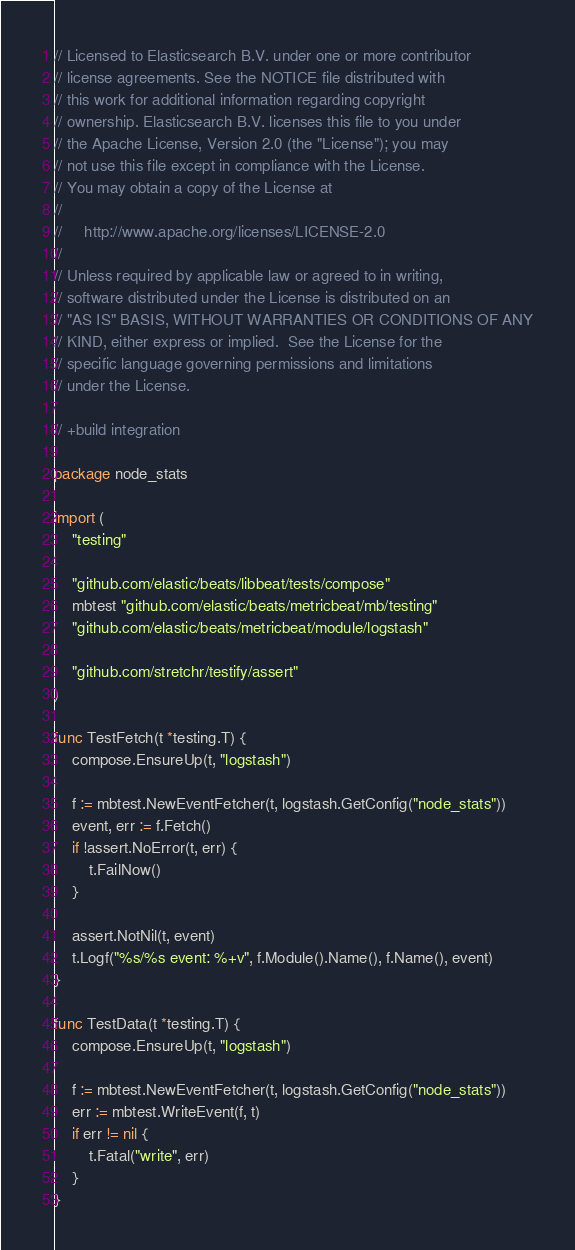<code> <loc_0><loc_0><loc_500><loc_500><_Go_>// Licensed to Elasticsearch B.V. under one or more contributor
// license agreements. See the NOTICE file distributed with
// this work for additional information regarding copyright
// ownership. Elasticsearch B.V. licenses this file to you under
// the Apache License, Version 2.0 (the "License"); you may
// not use this file except in compliance with the License.
// You may obtain a copy of the License at
//
//     http://www.apache.org/licenses/LICENSE-2.0
//
// Unless required by applicable law or agreed to in writing,
// software distributed under the License is distributed on an
// "AS IS" BASIS, WITHOUT WARRANTIES OR CONDITIONS OF ANY
// KIND, either express or implied.  See the License for the
// specific language governing permissions and limitations
// under the License.

// +build integration

package node_stats

import (
	"testing"

	"github.com/elastic/beats/libbeat/tests/compose"
	mbtest "github.com/elastic/beats/metricbeat/mb/testing"
	"github.com/elastic/beats/metricbeat/module/logstash"

	"github.com/stretchr/testify/assert"
)

func TestFetch(t *testing.T) {
	compose.EnsureUp(t, "logstash")

	f := mbtest.NewEventFetcher(t, logstash.GetConfig("node_stats"))
	event, err := f.Fetch()
	if !assert.NoError(t, err) {
		t.FailNow()
	}

	assert.NotNil(t, event)
	t.Logf("%s/%s event: %+v", f.Module().Name(), f.Name(), event)
}

func TestData(t *testing.T) {
	compose.EnsureUp(t, "logstash")

	f := mbtest.NewEventFetcher(t, logstash.GetConfig("node_stats"))
	err := mbtest.WriteEvent(f, t)
	if err != nil {
		t.Fatal("write", err)
	}
}
</code> 